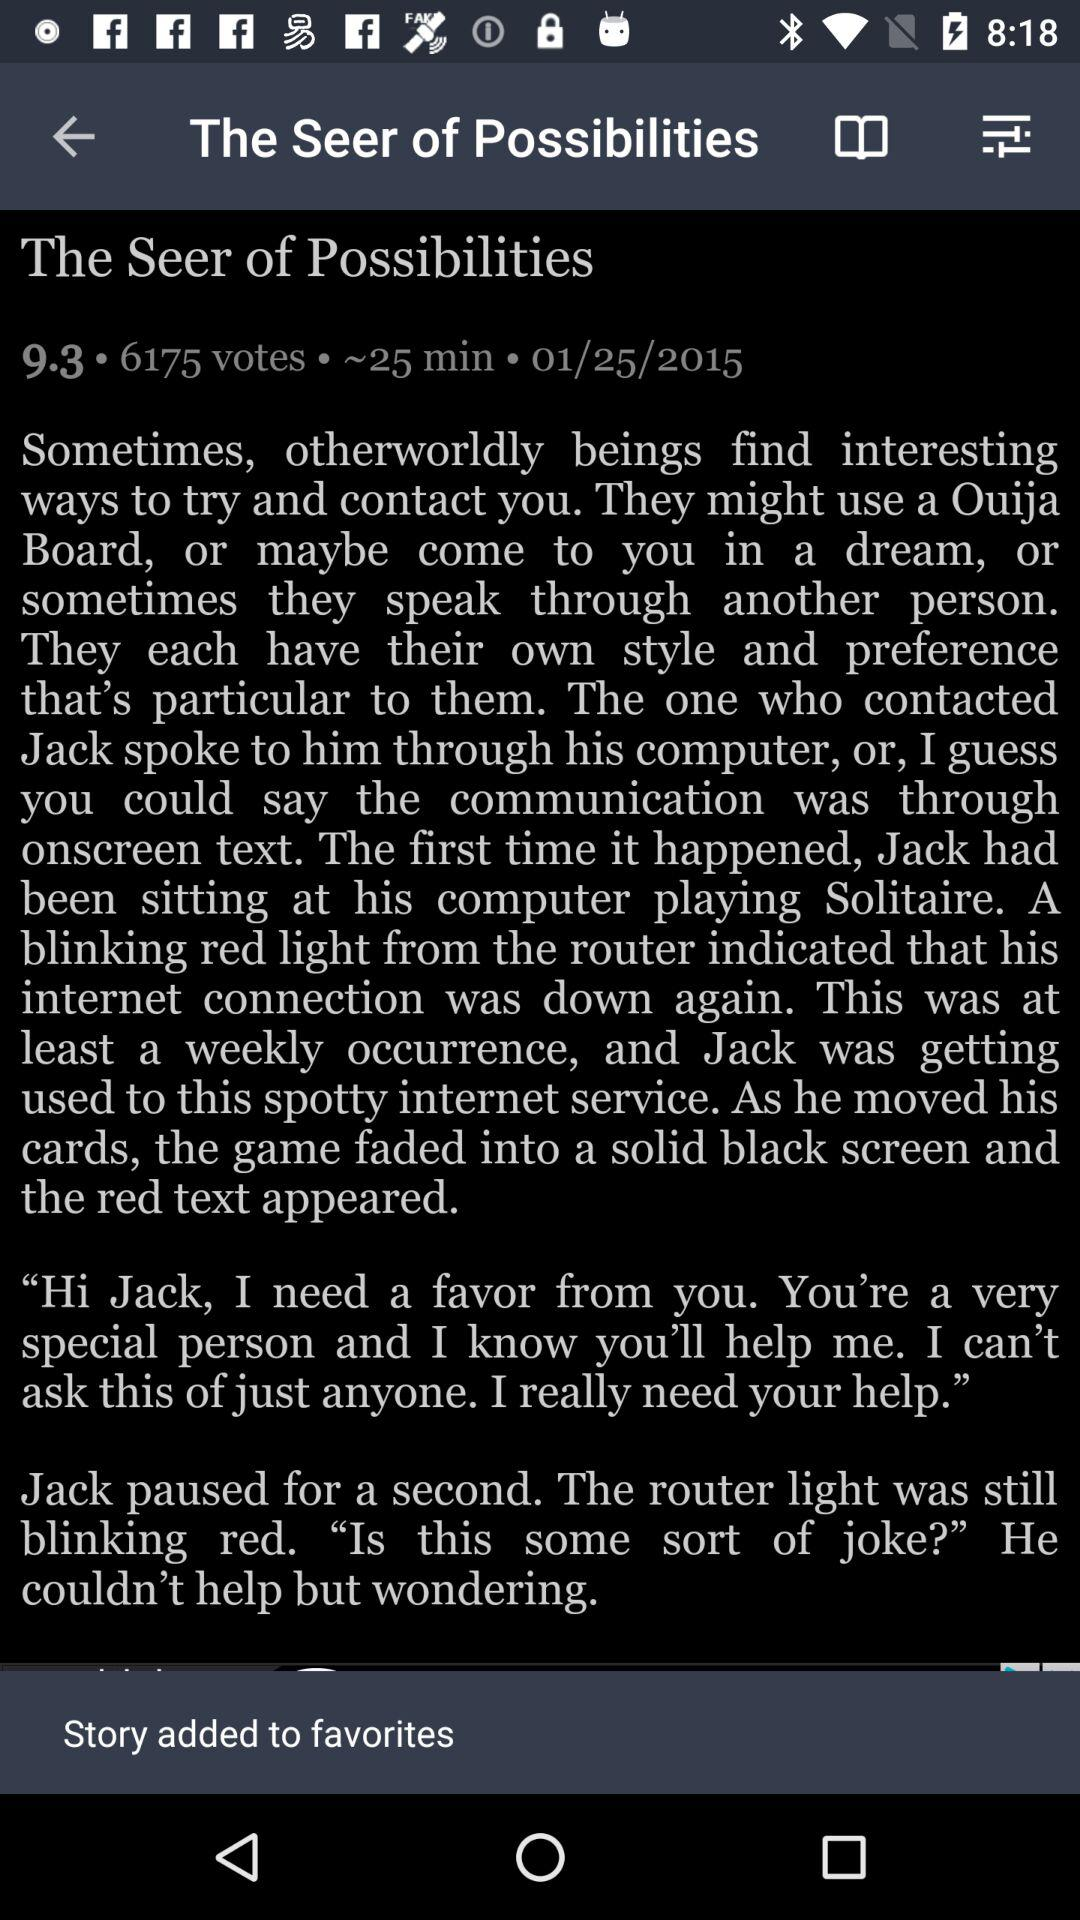What is the duration of "The Seer of Possibilities"? The duration of "The Seer of Possibilities" is approximately 25 minutes. 